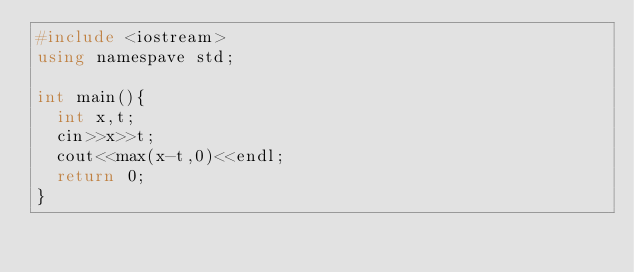<code> <loc_0><loc_0><loc_500><loc_500><_C++_>#include <iostream>
using namespave std;

int main(){
  int x,t;
  cin>>x>>t;
  cout<<max(x-t,0)<<endl;
  return 0;
}
</code> 